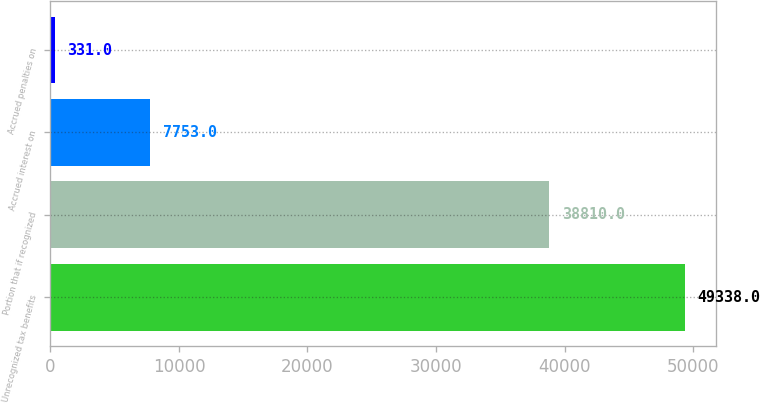Convert chart to OTSL. <chart><loc_0><loc_0><loc_500><loc_500><bar_chart><fcel>Unrecognized tax benefits<fcel>Portion that if recognized<fcel>Accrued interest on<fcel>Accrued penalties on<nl><fcel>49338<fcel>38810<fcel>7753<fcel>331<nl></chart> 